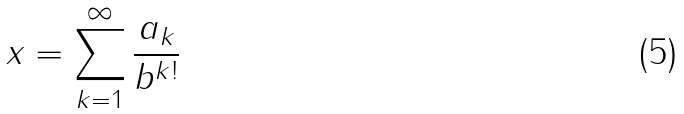Convert formula to latex. <formula><loc_0><loc_0><loc_500><loc_500>x = \sum _ { k = 1 } ^ { \infty } { \frac { a _ { k } } { b ^ { k ! } } }</formula> 